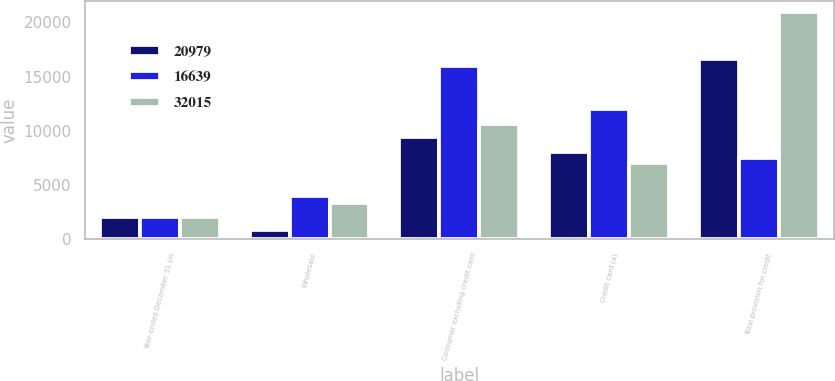Convert chart. <chart><loc_0><loc_0><loc_500><loc_500><stacked_bar_chart><ecel><fcel>Year ended December 31 (in<fcel>Wholesale<fcel>Consumer excluding credit card<fcel>Credit card (a)<fcel>Total provision for credit<nl><fcel>20979<fcel>2010<fcel>850<fcel>9452<fcel>8037<fcel>16639<nl><fcel>16639<fcel>2009<fcel>3974<fcel>16022<fcel>12019<fcel>7539.5<nl><fcel>32015<fcel>2008<fcel>3327<fcel>10610<fcel>7042<fcel>20979<nl></chart> 